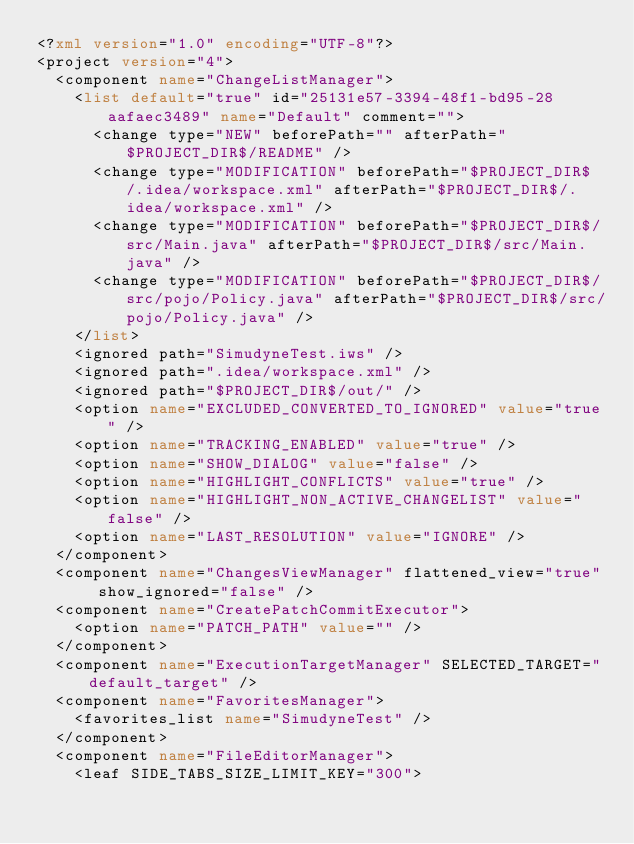<code> <loc_0><loc_0><loc_500><loc_500><_XML_><?xml version="1.0" encoding="UTF-8"?>
<project version="4">
  <component name="ChangeListManager">
    <list default="true" id="25131e57-3394-48f1-bd95-28aafaec3489" name="Default" comment="">
      <change type="NEW" beforePath="" afterPath="$PROJECT_DIR$/README" />
      <change type="MODIFICATION" beforePath="$PROJECT_DIR$/.idea/workspace.xml" afterPath="$PROJECT_DIR$/.idea/workspace.xml" />
      <change type="MODIFICATION" beforePath="$PROJECT_DIR$/src/Main.java" afterPath="$PROJECT_DIR$/src/Main.java" />
      <change type="MODIFICATION" beforePath="$PROJECT_DIR$/src/pojo/Policy.java" afterPath="$PROJECT_DIR$/src/pojo/Policy.java" />
    </list>
    <ignored path="SimudyneTest.iws" />
    <ignored path=".idea/workspace.xml" />
    <ignored path="$PROJECT_DIR$/out/" />
    <option name="EXCLUDED_CONVERTED_TO_IGNORED" value="true" />
    <option name="TRACKING_ENABLED" value="true" />
    <option name="SHOW_DIALOG" value="false" />
    <option name="HIGHLIGHT_CONFLICTS" value="true" />
    <option name="HIGHLIGHT_NON_ACTIVE_CHANGELIST" value="false" />
    <option name="LAST_RESOLUTION" value="IGNORE" />
  </component>
  <component name="ChangesViewManager" flattened_view="true" show_ignored="false" />
  <component name="CreatePatchCommitExecutor">
    <option name="PATCH_PATH" value="" />
  </component>
  <component name="ExecutionTargetManager" SELECTED_TARGET="default_target" />
  <component name="FavoritesManager">
    <favorites_list name="SimudyneTest" />
  </component>
  <component name="FileEditorManager">
    <leaf SIDE_TABS_SIZE_LIMIT_KEY="300"></code> 